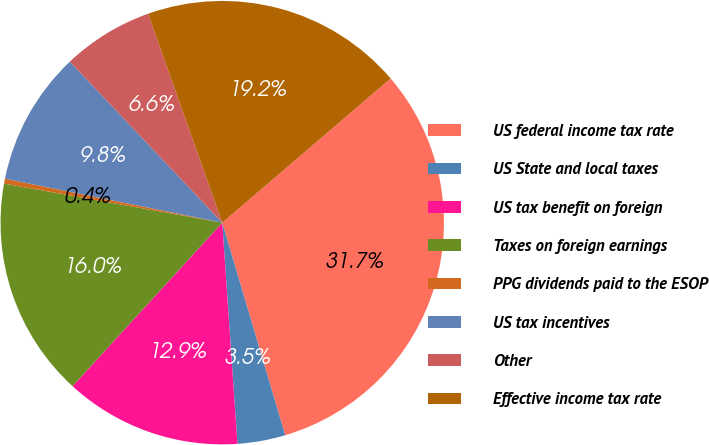Convert chart to OTSL. <chart><loc_0><loc_0><loc_500><loc_500><pie_chart><fcel>US federal income tax rate<fcel>US State and local taxes<fcel>US tax benefit on foreign<fcel>Taxes on foreign earnings<fcel>PPG dividends paid to the ESOP<fcel>US tax incentives<fcel>Other<fcel>Effective income tax rate<nl><fcel>31.69%<fcel>3.49%<fcel>12.89%<fcel>16.02%<fcel>0.36%<fcel>9.76%<fcel>6.63%<fcel>19.16%<nl></chart> 